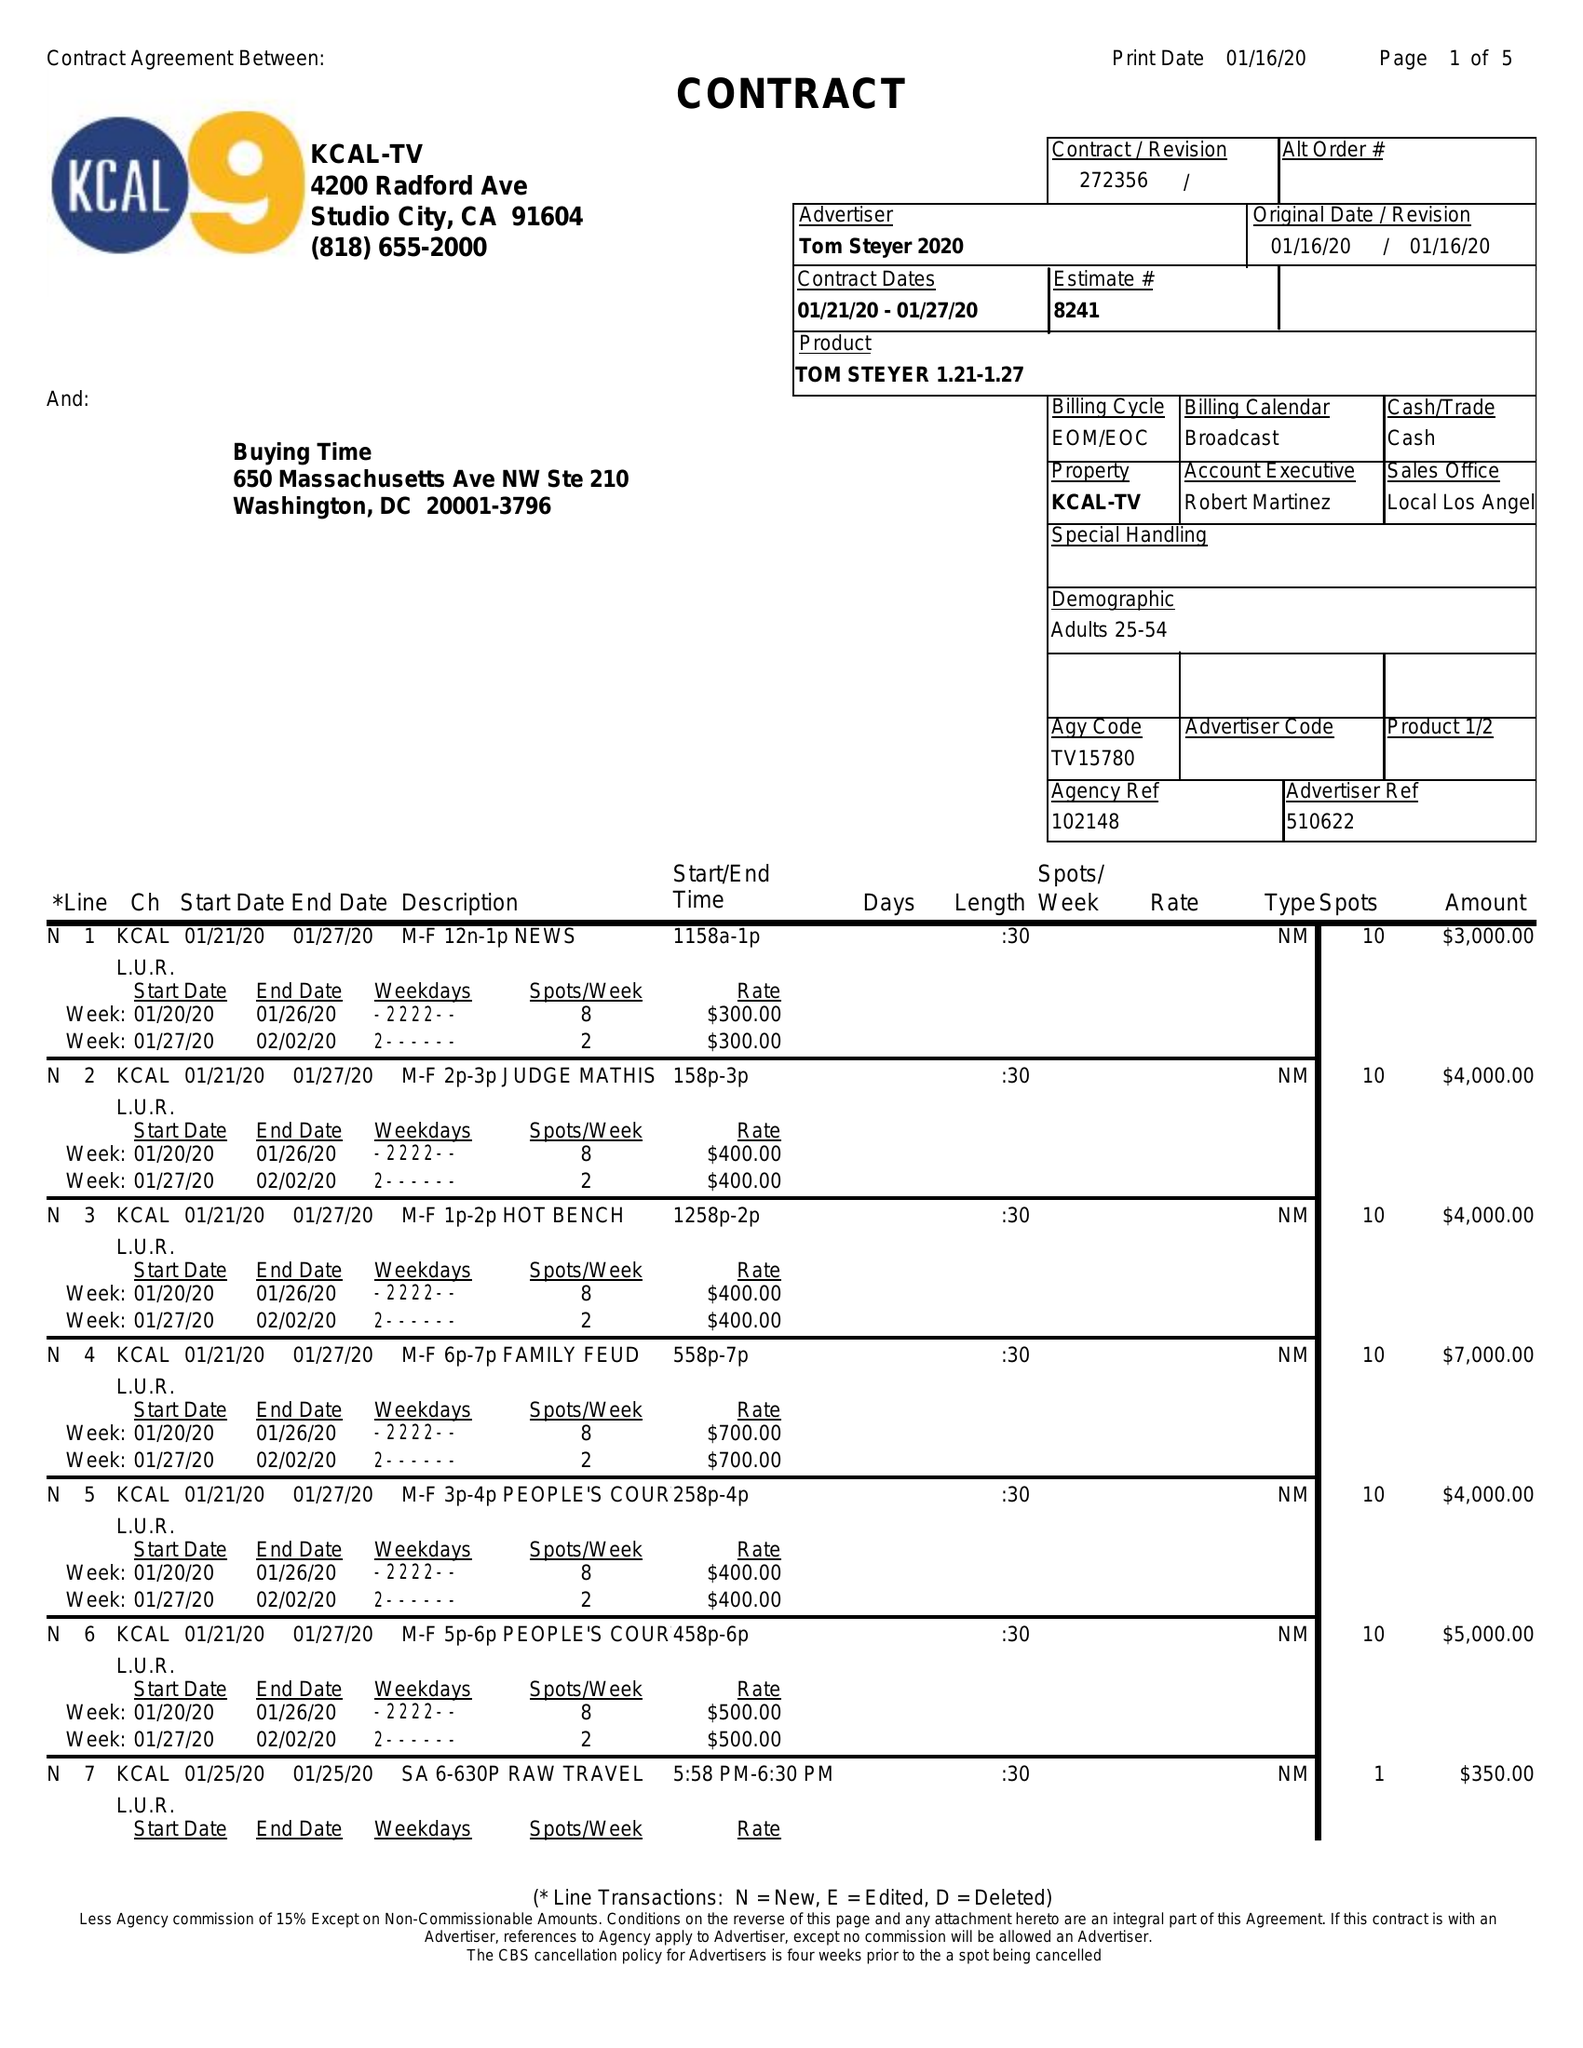What is the value for the contract_num?
Answer the question using a single word or phrase. 272356 